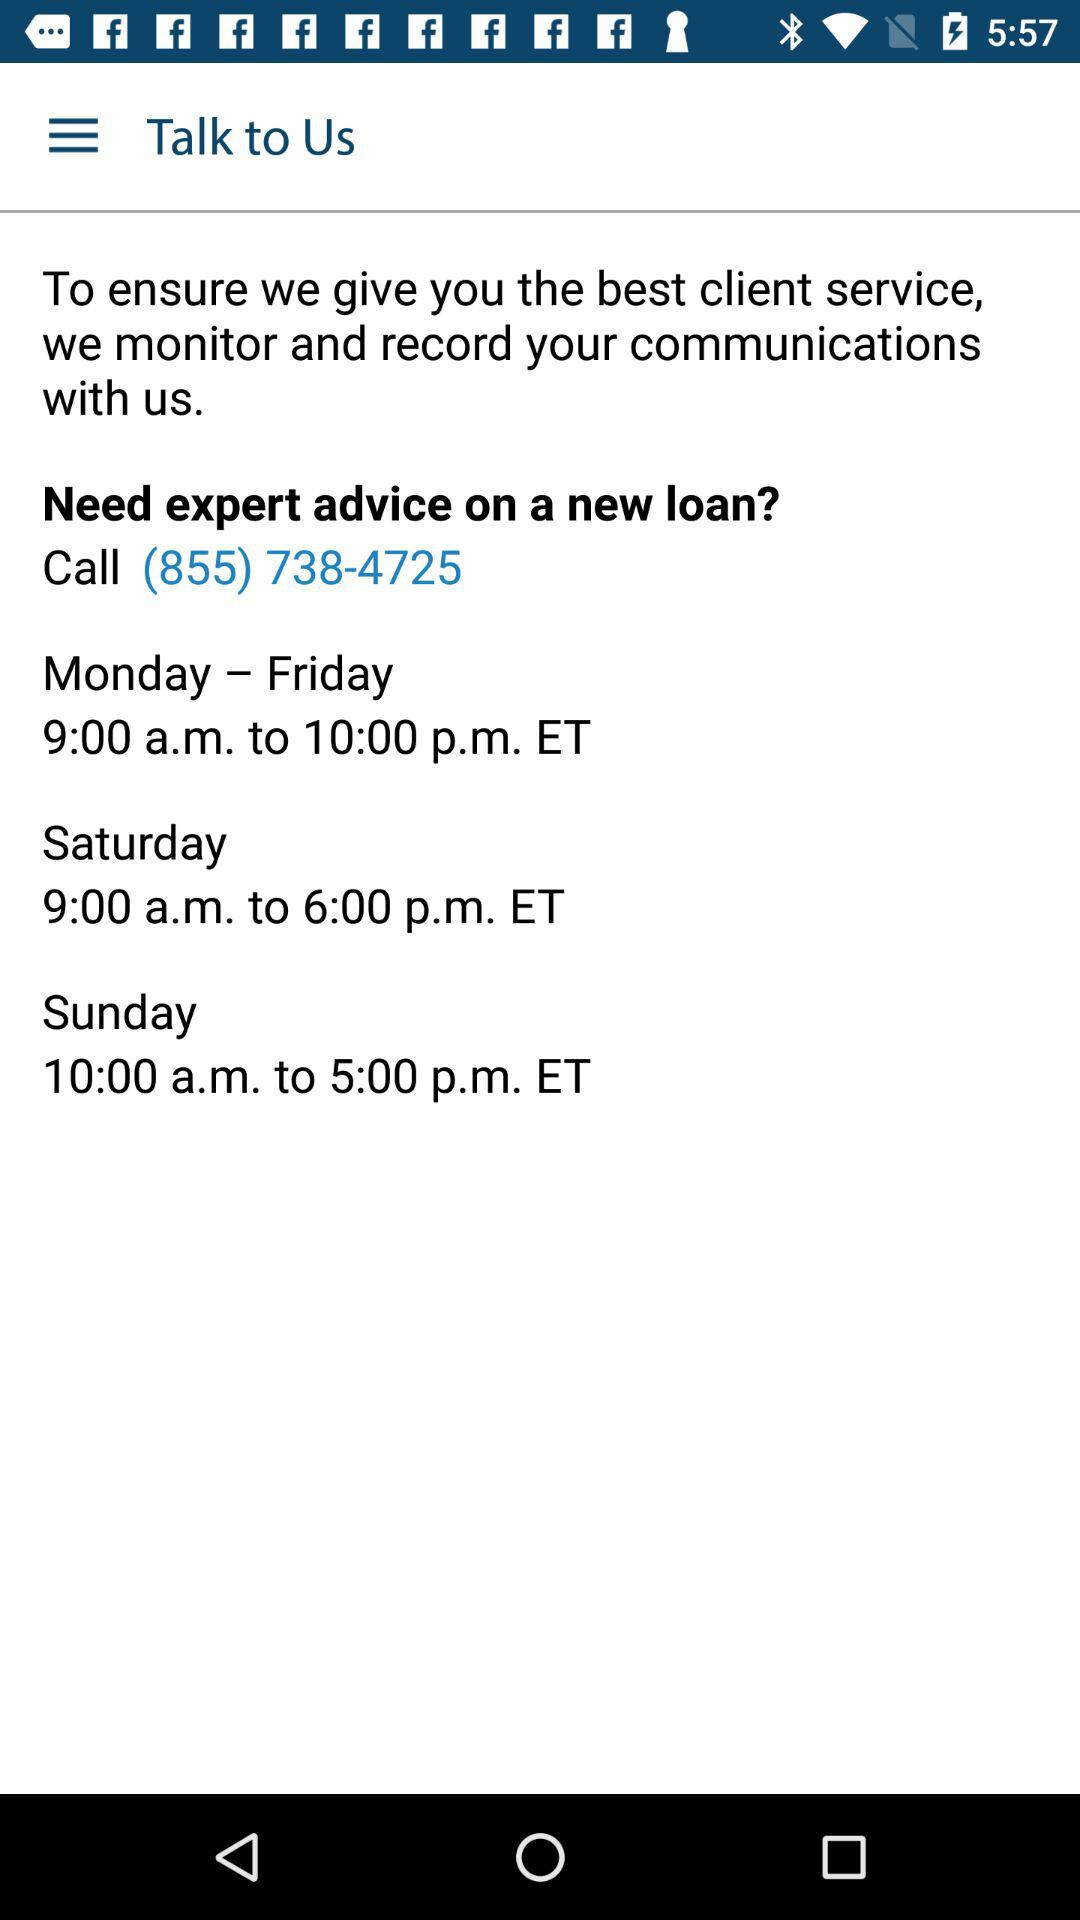What is the contact number? The contact number is (855) 738-4725. 